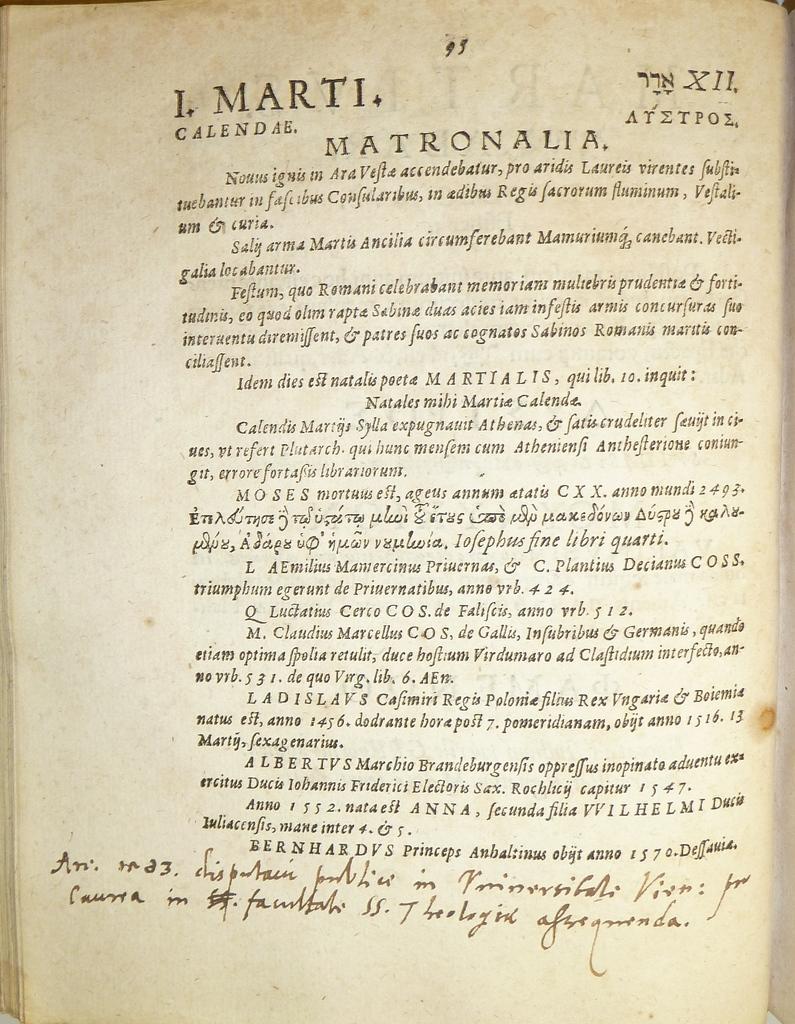What page number is printed at the top of the page?
Make the answer very short. Xii. 